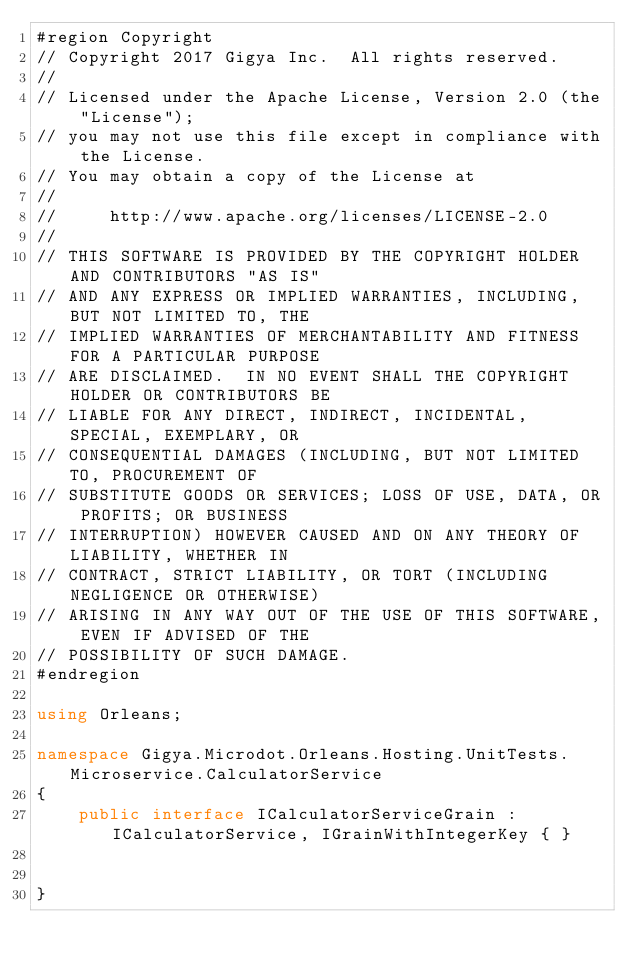<code> <loc_0><loc_0><loc_500><loc_500><_C#_>#region Copyright 
// Copyright 2017 Gigya Inc.  All rights reserved.
// 
// Licensed under the Apache License, Version 2.0 (the "License"); 
// you may not use this file except in compliance with the License.  
// You may obtain a copy of the License at
// 
//     http://www.apache.org/licenses/LICENSE-2.0
// 
// THIS SOFTWARE IS PROVIDED BY THE COPYRIGHT HOLDER AND CONTRIBUTORS "AS IS"
// AND ANY EXPRESS OR IMPLIED WARRANTIES, INCLUDING, BUT NOT LIMITED TO, THE
// IMPLIED WARRANTIES OF MERCHANTABILITY AND FITNESS FOR A PARTICULAR PURPOSE
// ARE DISCLAIMED.  IN NO EVENT SHALL THE COPYRIGHT HOLDER OR CONTRIBUTORS BE
// LIABLE FOR ANY DIRECT, INDIRECT, INCIDENTAL, SPECIAL, EXEMPLARY, OR
// CONSEQUENTIAL DAMAGES (INCLUDING, BUT NOT LIMITED TO, PROCUREMENT OF
// SUBSTITUTE GOODS OR SERVICES; LOSS OF USE, DATA, OR PROFITS; OR BUSINESS
// INTERRUPTION) HOWEVER CAUSED AND ON ANY THEORY OF LIABILITY, WHETHER IN
// CONTRACT, STRICT LIABILITY, OR TORT (INCLUDING NEGLIGENCE OR OTHERWISE)
// ARISING IN ANY WAY OUT OF THE USE OF THIS SOFTWARE, EVEN IF ADVISED OF THE
// POSSIBILITY OF SUCH DAMAGE.
#endregion

using Orleans;

namespace Gigya.Microdot.Orleans.Hosting.UnitTests.Microservice.CalculatorService
{
    public interface ICalculatorServiceGrain : ICalculatorService, IGrainWithIntegerKey { }

    
}</code> 